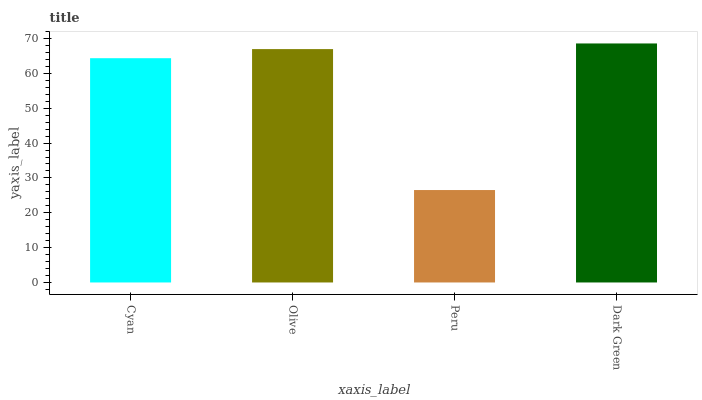Is Peru the minimum?
Answer yes or no. Yes. Is Dark Green the maximum?
Answer yes or no. Yes. Is Olive the minimum?
Answer yes or no. No. Is Olive the maximum?
Answer yes or no. No. Is Olive greater than Cyan?
Answer yes or no. Yes. Is Cyan less than Olive?
Answer yes or no. Yes. Is Cyan greater than Olive?
Answer yes or no. No. Is Olive less than Cyan?
Answer yes or no. No. Is Olive the high median?
Answer yes or no. Yes. Is Cyan the low median?
Answer yes or no. Yes. Is Dark Green the high median?
Answer yes or no. No. Is Dark Green the low median?
Answer yes or no. No. 